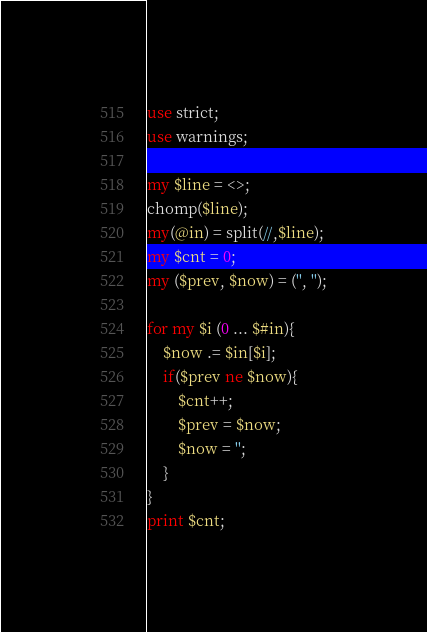<code> <loc_0><loc_0><loc_500><loc_500><_Perl_>use strict;
use warnings;

my $line = <>;
chomp($line);
my(@in) = split(//,$line);
my $cnt = 0;
my ($prev, $now) = ('', '');

for my $i (0 ... $#in){
	$now .= $in[$i];
	if($prev ne $now){
		$cnt++;
		$prev = $now;
		$now = '';
	}
}
print $cnt;
</code> 